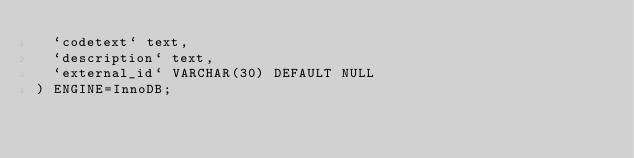Convert code to text. <code><loc_0><loc_0><loc_500><loc_500><_SQL_>  `codetext` text,
  `description` text,
  `external_id` VARCHAR(30) DEFAULT NULL
) ENGINE=InnoDB;

</code> 